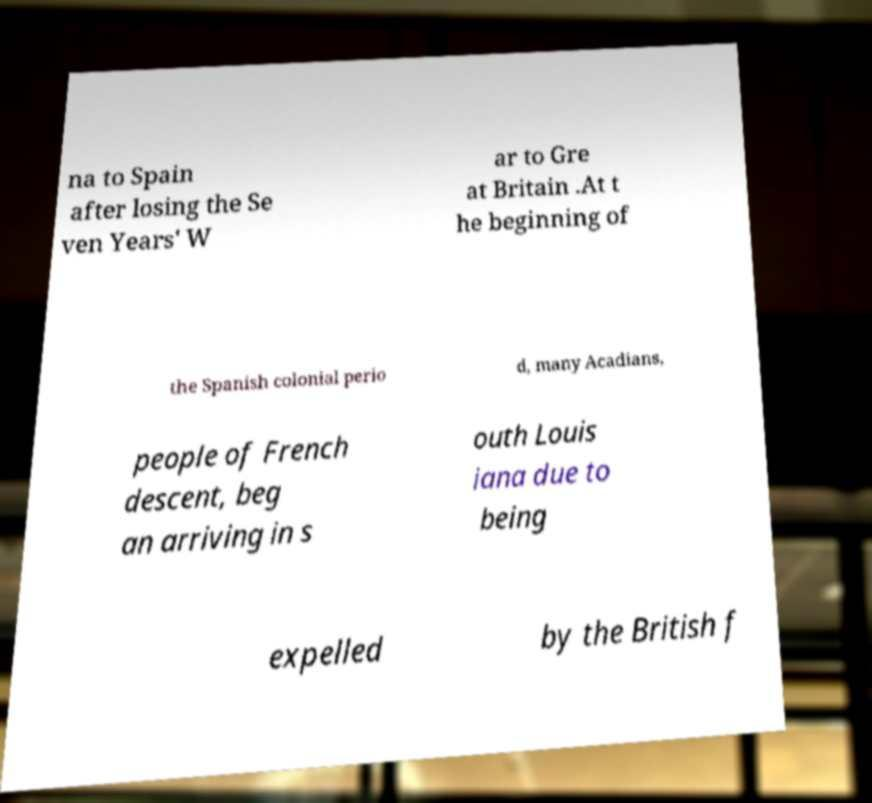I need the written content from this picture converted into text. Can you do that? na to Spain after losing the Se ven Years' W ar to Gre at Britain .At t he beginning of the Spanish colonial perio d, many Acadians, people of French descent, beg an arriving in s outh Louis iana due to being expelled by the British f 